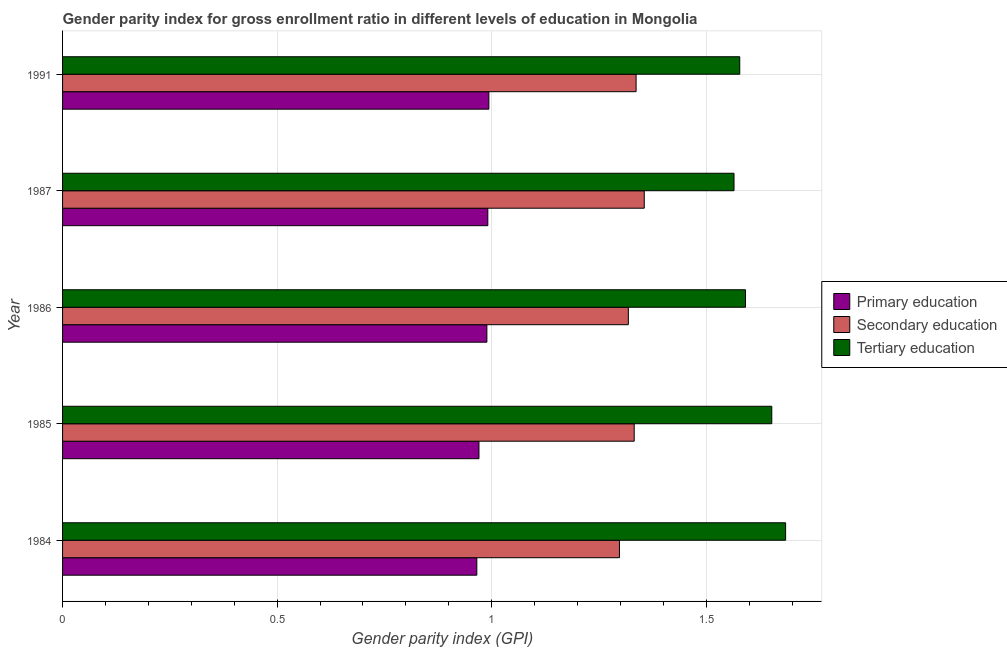How many groups of bars are there?
Ensure brevity in your answer.  5. How many bars are there on the 4th tick from the top?
Ensure brevity in your answer.  3. What is the label of the 4th group of bars from the top?
Give a very brief answer. 1985. What is the gender parity index in primary education in 1984?
Your response must be concise. 0.97. Across all years, what is the maximum gender parity index in tertiary education?
Ensure brevity in your answer.  1.69. Across all years, what is the minimum gender parity index in tertiary education?
Ensure brevity in your answer.  1.56. In which year was the gender parity index in primary education maximum?
Provide a short and direct response. 1991. In which year was the gender parity index in secondary education minimum?
Your answer should be very brief. 1984. What is the total gender parity index in tertiary education in the graph?
Offer a terse response. 8.07. What is the difference between the gender parity index in primary education in 1985 and that in 1986?
Offer a very short reply. -0.02. What is the difference between the gender parity index in secondary education in 1987 and the gender parity index in tertiary education in 1985?
Ensure brevity in your answer.  -0.3. What is the average gender parity index in secondary education per year?
Ensure brevity in your answer.  1.33. In the year 1985, what is the difference between the gender parity index in tertiary education and gender parity index in secondary education?
Keep it short and to the point. 0.32. In how many years, is the gender parity index in primary education greater than 0.30000000000000004 ?
Offer a terse response. 5. Is the gender parity index in primary education in 1984 less than that in 1987?
Your answer should be compact. Yes. What is the difference between the highest and the second highest gender parity index in secondary education?
Your answer should be compact. 0.02. What is the difference between the highest and the lowest gender parity index in tertiary education?
Offer a terse response. 0.12. In how many years, is the gender parity index in tertiary education greater than the average gender parity index in tertiary education taken over all years?
Your response must be concise. 2. Is the sum of the gender parity index in tertiary education in 1985 and 1986 greater than the maximum gender parity index in primary education across all years?
Keep it short and to the point. Yes. What does the 2nd bar from the top in 1985 represents?
Offer a very short reply. Secondary education. What does the 3rd bar from the bottom in 1986 represents?
Provide a succinct answer. Tertiary education. Is it the case that in every year, the sum of the gender parity index in primary education and gender parity index in secondary education is greater than the gender parity index in tertiary education?
Your response must be concise. Yes. How many years are there in the graph?
Offer a very short reply. 5. What is the difference between two consecutive major ticks on the X-axis?
Provide a short and direct response. 0.5. Does the graph contain any zero values?
Make the answer very short. No. Does the graph contain grids?
Make the answer very short. Yes. How many legend labels are there?
Offer a very short reply. 3. How are the legend labels stacked?
Give a very brief answer. Vertical. What is the title of the graph?
Offer a very short reply. Gender parity index for gross enrollment ratio in different levels of education in Mongolia. What is the label or title of the X-axis?
Ensure brevity in your answer.  Gender parity index (GPI). What is the Gender parity index (GPI) in Primary education in 1984?
Give a very brief answer. 0.97. What is the Gender parity index (GPI) in Secondary education in 1984?
Offer a terse response. 1.3. What is the Gender parity index (GPI) in Tertiary education in 1984?
Your answer should be compact. 1.69. What is the Gender parity index (GPI) of Primary education in 1985?
Your response must be concise. 0.97. What is the Gender parity index (GPI) in Secondary education in 1985?
Keep it short and to the point. 1.33. What is the Gender parity index (GPI) of Tertiary education in 1985?
Your answer should be very brief. 1.65. What is the Gender parity index (GPI) of Primary education in 1986?
Offer a very short reply. 0.99. What is the Gender parity index (GPI) in Secondary education in 1986?
Provide a short and direct response. 1.32. What is the Gender parity index (GPI) of Tertiary education in 1986?
Ensure brevity in your answer.  1.59. What is the Gender parity index (GPI) in Primary education in 1987?
Provide a short and direct response. 0.99. What is the Gender parity index (GPI) of Secondary education in 1987?
Offer a terse response. 1.36. What is the Gender parity index (GPI) in Tertiary education in 1987?
Offer a very short reply. 1.56. What is the Gender parity index (GPI) in Primary education in 1991?
Give a very brief answer. 0.99. What is the Gender parity index (GPI) in Secondary education in 1991?
Your answer should be very brief. 1.34. What is the Gender parity index (GPI) of Tertiary education in 1991?
Offer a terse response. 1.58. Across all years, what is the maximum Gender parity index (GPI) of Primary education?
Offer a terse response. 0.99. Across all years, what is the maximum Gender parity index (GPI) in Secondary education?
Make the answer very short. 1.36. Across all years, what is the maximum Gender parity index (GPI) of Tertiary education?
Your response must be concise. 1.69. Across all years, what is the minimum Gender parity index (GPI) in Primary education?
Offer a terse response. 0.97. Across all years, what is the minimum Gender parity index (GPI) in Secondary education?
Keep it short and to the point. 1.3. Across all years, what is the minimum Gender parity index (GPI) in Tertiary education?
Keep it short and to the point. 1.56. What is the total Gender parity index (GPI) of Primary education in the graph?
Keep it short and to the point. 4.91. What is the total Gender parity index (GPI) of Secondary education in the graph?
Your answer should be compact. 6.64. What is the total Gender parity index (GPI) of Tertiary education in the graph?
Your answer should be compact. 8.07. What is the difference between the Gender parity index (GPI) of Primary education in 1984 and that in 1985?
Provide a short and direct response. -0.01. What is the difference between the Gender parity index (GPI) in Secondary education in 1984 and that in 1985?
Provide a short and direct response. -0.03. What is the difference between the Gender parity index (GPI) in Tertiary education in 1984 and that in 1985?
Provide a short and direct response. 0.03. What is the difference between the Gender parity index (GPI) of Primary education in 1984 and that in 1986?
Your answer should be compact. -0.02. What is the difference between the Gender parity index (GPI) of Secondary education in 1984 and that in 1986?
Offer a terse response. -0.02. What is the difference between the Gender parity index (GPI) in Tertiary education in 1984 and that in 1986?
Make the answer very short. 0.09. What is the difference between the Gender parity index (GPI) in Primary education in 1984 and that in 1987?
Your answer should be very brief. -0.03. What is the difference between the Gender parity index (GPI) of Secondary education in 1984 and that in 1987?
Keep it short and to the point. -0.06. What is the difference between the Gender parity index (GPI) in Tertiary education in 1984 and that in 1987?
Provide a succinct answer. 0.12. What is the difference between the Gender parity index (GPI) of Primary education in 1984 and that in 1991?
Keep it short and to the point. -0.03. What is the difference between the Gender parity index (GPI) of Secondary education in 1984 and that in 1991?
Your response must be concise. -0.04. What is the difference between the Gender parity index (GPI) of Tertiary education in 1984 and that in 1991?
Your response must be concise. 0.11. What is the difference between the Gender parity index (GPI) of Primary education in 1985 and that in 1986?
Ensure brevity in your answer.  -0.02. What is the difference between the Gender parity index (GPI) in Secondary education in 1985 and that in 1986?
Ensure brevity in your answer.  0.01. What is the difference between the Gender parity index (GPI) in Tertiary education in 1985 and that in 1986?
Make the answer very short. 0.06. What is the difference between the Gender parity index (GPI) of Primary education in 1985 and that in 1987?
Ensure brevity in your answer.  -0.02. What is the difference between the Gender parity index (GPI) in Secondary education in 1985 and that in 1987?
Your response must be concise. -0.02. What is the difference between the Gender parity index (GPI) of Tertiary education in 1985 and that in 1987?
Your response must be concise. 0.09. What is the difference between the Gender parity index (GPI) of Primary education in 1985 and that in 1991?
Provide a succinct answer. -0.02. What is the difference between the Gender parity index (GPI) in Secondary education in 1985 and that in 1991?
Make the answer very short. -0. What is the difference between the Gender parity index (GPI) of Tertiary education in 1985 and that in 1991?
Make the answer very short. 0.07. What is the difference between the Gender parity index (GPI) of Primary education in 1986 and that in 1987?
Offer a terse response. -0. What is the difference between the Gender parity index (GPI) of Secondary education in 1986 and that in 1987?
Your answer should be compact. -0.04. What is the difference between the Gender parity index (GPI) of Tertiary education in 1986 and that in 1987?
Provide a succinct answer. 0.03. What is the difference between the Gender parity index (GPI) in Primary education in 1986 and that in 1991?
Keep it short and to the point. -0. What is the difference between the Gender parity index (GPI) in Secondary education in 1986 and that in 1991?
Your answer should be compact. -0.02. What is the difference between the Gender parity index (GPI) in Tertiary education in 1986 and that in 1991?
Your answer should be very brief. 0.01. What is the difference between the Gender parity index (GPI) in Primary education in 1987 and that in 1991?
Give a very brief answer. -0. What is the difference between the Gender parity index (GPI) of Secondary education in 1987 and that in 1991?
Provide a short and direct response. 0.02. What is the difference between the Gender parity index (GPI) in Tertiary education in 1987 and that in 1991?
Your answer should be very brief. -0.01. What is the difference between the Gender parity index (GPI) in Primary education in 1984 and the Gender parity index (GPI) in Secondary education in 1985?
Your answer should be very brief. -0.37. What is the difference between the Gender parity index (GPI) in Primary education in 1984 and the Gender parity index (GPI) in Tertiary education in 1985?
Provide a succinct answer. -0.69. What is the difference between the Gender parity index (GPI) of Secondary education in 1984 and the Gender parity index (GPI) of Tertiary education in 1985?
Make the answer very short. -0.35. What is the difference between the Gender parity index (GPI) of Primary education in 1984 and the Gender parity index (GPI) of Secondary education in 1986?
Keep it short and to the point. -0.35. What is the difference between the Gender parity index (GPI) of Primary education in 1984 and the Gender parity index (GPI) of Tertiary education in 1986?
Provide a short and direct response. -0.63. What is the difference between the Gender parity index (GPI) of Secondary education in 1984 and the Gender parity index (GPI) of Tertiary education in 1986?
Make the answer very short. -0.29. What is the difference between the Gender parity index (GPI) in Primary education in 1984 and the Gender parity index (GPI) in Secondary education in 1987?
Keep it short and to the point. -0.39. What is the difference between the Gender parity index (GPI) of Primary education in 1984 and the Gender parity index (GPI) of Tertiary education in 1987?
Offer a very short reply. -0.6. What is the difference between the Gender parity index (GPI) in Secondary education in 1984 and the Gender parity index (GPI) in Tertiary education in 1987?
Give a very brief answer. -0.27. What is the difference between the Gender parity index (GPI) in Primary education in 1984 and the Gender parity index (GPI) in Secondary education in 1991?
Provide a short and direct response. -0.37. What is the difference between the Gender parity index (GPI) of Primary education in 1984 and the Gender parity index (GPI) of Tertiary education in 1991?
Give a very brief answer. -0.61. What is the difference between the Gender parity index (GPI) of Secondary education in 1984 and the Gender parity index (GPI) of Tertiary education in 1991?
Make the answer very short. -0.28. What is the difference between the Gender parity index (GPI) in Primary education in 1985 and the Gender parity index (GPI) in Secondary education in 1986?
Your answer should be compact. -0.35. What is the difference between the Gender parity index (GPI) of Primary education in 1985 and the Gender parity index (GPI) of Tertiary education in 1986?
Keep it short and to the point. -0.62. What is the difference between the Gender parity index (GPI) of Secondary education in 1985 and the Gender parity index (GPI) of Tertiary education in 1986?
Keep it short and to the point. -0.26. What is the difference between the Gender parity index (GPI) in Primary education in 1985 and the Gender parity index (GPI) in Secondary education in 1987?
Your answer should be very brief. -0.39. What is the difference between the Gender parity index (GPI) in Primary education in 1985 and the Gender parity index (GPI) in Tertiary education in 1987?
Your answer should be compact. -0.59. What is the difference between the Gender parity index (GPI) in Secondary education in 1985 and the Gender parity index (GPI) in Tertiary education in 1987?
Offer a terse response. -0.23. What is the difference between the Gender parity index (GPI) in Primary education in 1985 and the Gender parity index (GPI) in Secondary education in 1991?
Your answer should be compact. -0.37. What is the difference between the Gender parity index (GPI) of Primary education in 1985 and the Gender parity index (GPI) of Tertiary education in 1991?
Ensure brevity in your answer.  -0.61. What is the difference between the Gender parity index (GPI) in Secondary education in 1985 and the Gender parity index (GPI) in Tertiary education in 1991?
Offer a terse response. -0.25. What is the difference between the Gender parity index (GPI) of Primary education in 1986 and the Gender parity index (GPI) of Secondary education in 1987?
Your answer should be compact. -0.37. What is the difference between the Gender parity index (GPI) of Primary education in 1986 and the Gender parity index (GPI) of Tertiary education in 1987?
Make the answer very short. -0.58. What is the difference between the Gender parity index (GPI) of Secondary education in 1986 and the Gender parity index (GPI) of Tertiary education in 1987?
Ensure brevity in your answer.  -0.25. What is the difference between the Gender parity index (GPI) in Primary education in 1986 and the Gender parity index (GPI) in Secondary education in 1991?
Make the answer very short. -0.35. What is the difference between the Gender parity index (GPI) in Primary education in 1986 and the Gender parity index (GPI) in Tertiary education in 1991?
Offer a very short reply. -0.59. What is the difference between the Gender parity index (GPI) of Secondary education in 1986 and the Gender parity index (GPI) of Tertiary education in 1991?
Your response must be concise. -0.26. What is the difference between the Gender parity index (GPI) in Primary education in 1987 and the Gender parity index (GPI) in Secondary education in 1991?
Provide a short and direct response. -0.35. What is the difference between the Gender parity index (GPI) of Primary education in 1987 and the Gender parity index (GPI) of Tertiary education in 1991?
Give a very brief answer. -0.59. What is the difference between the Gender parity index (GPI) in Secondary education in 1987 and the Gender parity index (GPI) in Tertiary education in 1991?
Your response must be concise. -0.22. What is the average Gender parity index (GPI) of Primary education per year?
Ensure brevity in your answer.  0.98. What is the average Gender parity index (GPI) of Secondary education per year?
Offer a very short reply. 1.33. What is the average Gender parity index (GPI) in Tertiary education per year?
Your answer should be very brief. 1.61. In the year 1984, what is the difference between the Gender parity index (GPI) of Primary education and Gender parity index (GPI) of Secondary education?
Ensure brevity in your answer.  -0.33. In the year 1984, what is the difference between the Gender parity index (GPI) of Primary education and Gender parity index (GPI) of Tertiary education?
Provide a succinct answer. -0.72. In the year 1984, what is the difference between the Gender parity index (GPI) in Secondary education and Gender parity index (GPI) in Tertiary education?
Your answer should be very brief. -0.39. In the year 1985, what is the difference between the Gender parity index (GPI) in Primary education and Gender parity index (GPI) in Secondary education?
Provide a short and direct response. -0.36. In the year 1985, what is the difference between the Gender parity index (GPI) in Primary education and Gender parity index (GPI) in Tertiary education?
Give a very brief answer. -0.68. In the year 1985, what is the difference between the Gender parity index (GPI) in Secondary education and Gender parity index (GPI) in Tertiary education?
Offer a very short reply. -0.32. In the year 1986, what is the difference between the Gender parity index (GPI) of Primary education and Gender parity index (GPI) of Secondary education?
Make the answer very short. -0.33. In the year 1986, what is the difference between the Gender parity index (GPI) in Primary education and Gender parity index (GPI) in Tertiary education?
Keep it short and to the point. -0.6. In the year 1986, what is the difference between the Gender parity index (GPI) of Secondary education and Gender parity index (GPI) of Tertiary education?
Provide a succinct answer. -0.27. In the year 1987, what is the difference between the Gender parity index (GPI) in Primary education and Gender parity index (GPI) in Secondary education?
Provide a succinct answer. -0.36. In the year 1987, what is the difference between the Gender parity index (GPI) in Primary education and Gender parity index (GPI) in Tertiary education?
Your answer should be very brief. -0.57. In the year 1987, what is the difference between the Gender parity index (GPI) in Secondary education and Gender parity index (GPI) in Tertiary education?
Keep it short and to the point. -0.21. In the year 1991, what is the difference between the Gender parity index (GPI) of Primary education and Gender parity index (GPI) of Secondary education?
Your answer should be compact. -0.34. In the year 1991, what is the difference between the Gender parity index (GPI) in Primary education and Gender parity index (GPI) in Tertiary education?
Provide a succinct answer. -0.58. In the year 1991, what is the difference between the Gender parity index (GPI) in Secondary education and Gender parity index (GPI) in Tertiary education?
Make the answer very short. -0.24. What is the ratio of the Gender parity index (GPI) of Secondary education in 1984 to that in 1985?
Provide a short and direct response. 0.97. What is the ratio of the Gender parity index (GPI) in Tertiary education in 1984 to that in 1985?
Your response must be concise. 1.02. What is the ratio of the Gender parity index (GPI) of Primary education in 1984 to that in 1986?
Offer a terse response. 0.98. What is the ratio of the Gender parity index (GPI) in Secondary education in 1984 to that in 1986?
Offer a terse response. 0.98. What is the ratio of the Gender parity index (GPI) of Tertiary education in 1984 to that in 1986?
Your response must be concise. 1.06. What is the ratio of the Gender parity index (GPI) in Primary education in 1984 to that in 1987?
Offer a terse response. 0.97. What is the ratio of the Gender parity index (GPI) in Secondary education in 1984 to that in 1987?
Your answer should be compact. 0.96. What is the ratio of the Gender parity index (GPI) in Tertiary education in 1984 to that in 1987?
Give a very brief answer. 1.08. What is the ratio of the Gender parity index (GPI) in Primary education in 1984 to that in 1991?
Offer a very short reply. 0.97. What is the ratio of the Gender parity index (GPI) of Secondary education in 1984 to that in 1991?
Offer a very short reply. 0.97. What is the ratio of the Gender parity index (GPI) of Tertiary education in 1984 to that in 1991?
Keep it short and to the point. 1.07. What is the ratio of the Gender parity index (GPI) in Primary education in 1985 to that in 1986?
Provide a succinct answer. 0.98. What is the ratio of the Gender parity index (GPI) of Secondary education in 1985 to that in 1986?
Ensure brevity in your answer.  1.01. What is the ratio of the Gender parity index (GPI) of Primary education in 1985 to that in 1987?
Ensure brevity in your answer.  0.98. What is the ratio of the Gender parity index (GPI) in Secondary education in 1985 to that in 1987?
Keep it short and to the point. 0.98. What is the ratio of the Gender parity index (GPI) in Tertiary education in 1985 to that in 1987?
Provide a short and direct response. 1.06. What is the ratio of the Gender parity index (GPI) in Primary education in 1985 to that in 1991?
Provide a short and direct response. 0.98. What is the ratio of the Gender parity index (GPI) of Secondary education in 1985 to that in 1991?
Provide a succinct answer. 1. What is the ratio of the Gender parity index (GPI) of Tertiary education in 1985 to that in 1991?
Your response must be concise. 1.05. What is the ratio of the Gender parity index (GPI) in Primary education in 1986 to that in 1987?
Provide a succinct answer. 1. What is the ratio of the Gender parity index (GPI) of Secondary education in 1986 to that in 1987?
Provide a short and direct response. 0.97. What is the ratio of the Gender parity index (GPI) of Secondary education in 1986 to that in 1991?
Provide a short and direct response. 0.99. What is the ratio of the Gender parity index (GPI) of Tertiary education in 1986 to that in 1991?
Provide a short and direct response. 1.01. What is the ratio of the Gender parity index (GPI) in Primary education in 1987 to that in 1991?
Keep it short and to the point. 1. What is the ratio of the Gender parity index (GPI) of Secondary education in 1987 to that in 1991?
Offer a very short reply. 1.01. What is the difference between the highest and the second highest Gender parity index (GPI) of Primary education?
Give a very brief answer. 0. What is the difference between the highest and the second highest Gender parity index (GPI) of Secondary education?
Your answer should be compact. 0.02. What is the difference between the highest and the second highest Gender parity index (GPI) in Tertiary education?
Offer a terse response. 0.03. What is the difference between the highest and the lowest Gender parity index (GPI) in Primary education?
Offer a very short reply. 0.03. What is the difference between the highest and the lowest Gender parity index (GPI) of Secondary education?
Your answer should be compact. 0.06. What is the difference between the highest and the lowest Gender parity index (GPI) of Tertiary education?
Give a very brief answer. 0.12. 